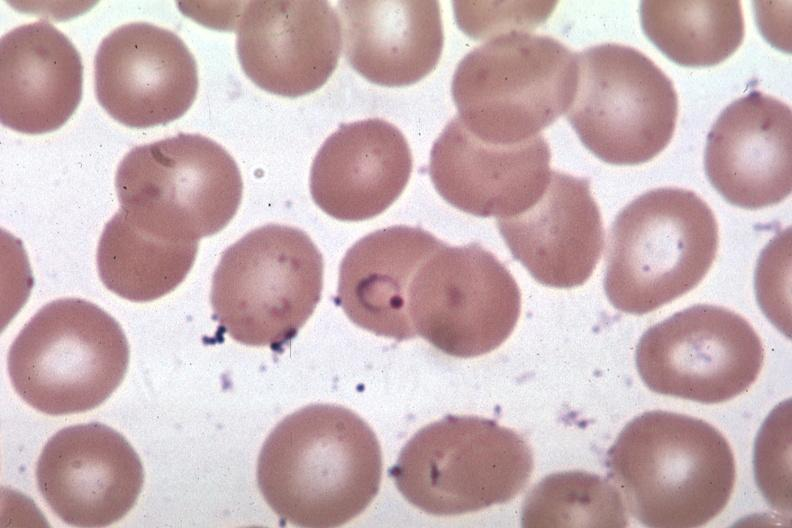what is present?
Answer the question using a single word or phrase. Hematologic 